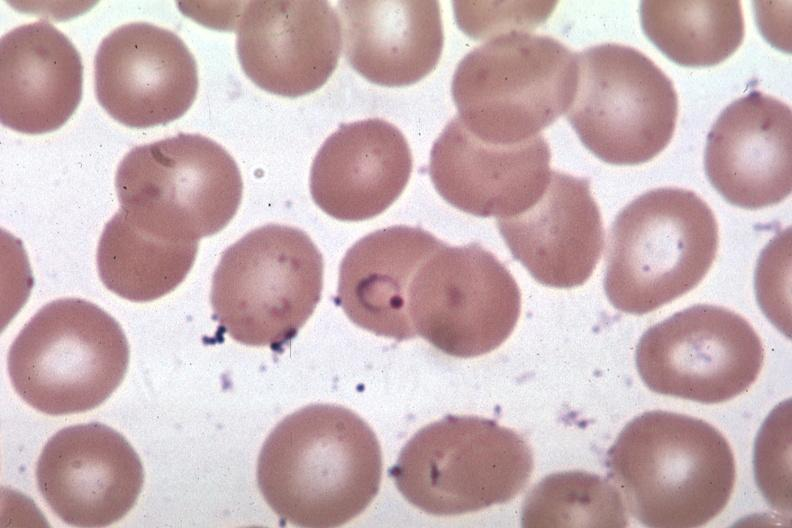what is present?
Answer the question using a single word or phrase. Hematologic 